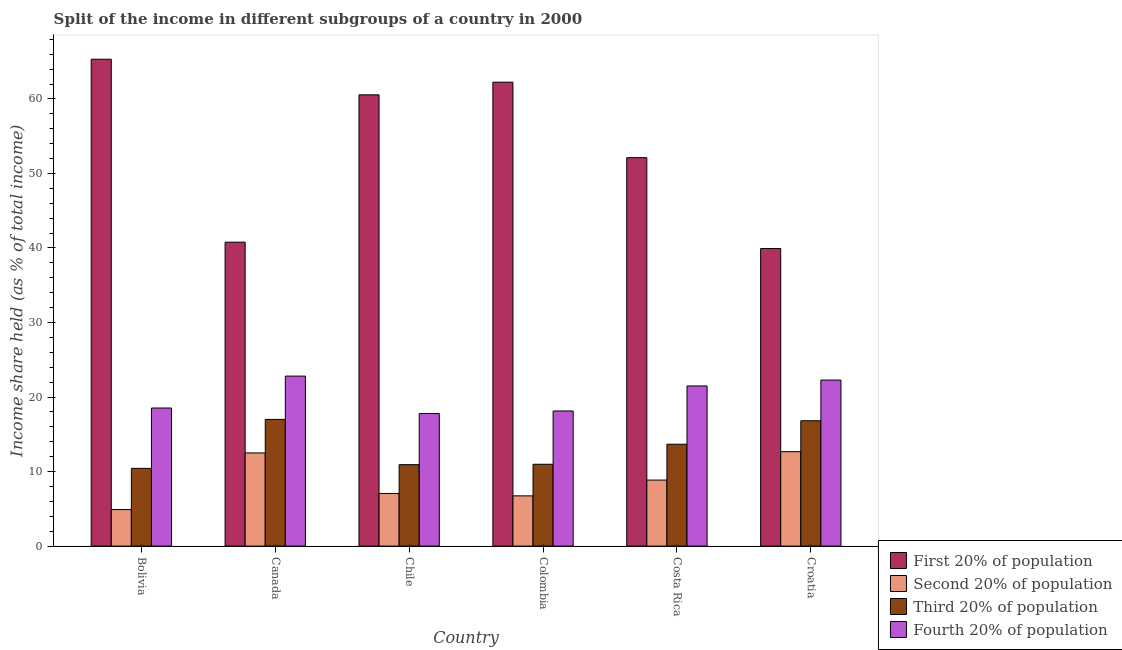How many different coloured bars are there?
Keep it short and to the point. 4. How many groups of bars are there?
Provide a succinct answer. 6. Are the number of bars per tick equal to the number of legend labels?
Give a very brief answer. Yes. Are the number of bars on each tick of the X-axis equal?
Ensure brevity in your answer.  Yes. How many bars are there on the 2nd tick from the right?
Give a very brief answer. 4. What is the label of the 4th group of bars from the left?
Offer a terse response. Colombia. What is the share of the income held by first 20% of the population in Costa Rica?
Ensure brevity in your answer.  52.12. Across all countries, what is the maximum share of the income held by first 20% of the population?
Offer a terse response. 65.33. Across all countries, what is the minimum share of the income held by first 20% of the population?
Provide a succinct answer. 39.93. What is the total share of the income held by second 20% of the population in the graph?
Provide a succinct answer. 52.73. What is the difference between the share of the income held by first 20% of the population in Chile and that in Croatia?
Provide a short and direct response. 20.62. What is the difference between the share of the income held by third 20% of the population in Chile and the share of the income held by second 20% of the population in Costa Rica?
Offer a very short reply. 2.07. What is the average share of the income held by fourth 20% of the population per country?
Offer a terse response. 20.17. What is the difference between the share of the income held by third 20% of the population and share of the income held by second 20% of the population in Costa Rica?
Provide a short and direct response. 4.81. In how many countries, is the share of the income held by third 20% of the population greater than 16 %?
Your answer should be compact. 2. What is the ratio of the share of the income held by second 20% of the population in Colombia to that in Costa Rica?
Ensure brevity in your answer.  0.76. Is the difference between the share of the income held by second 20% of the population in Bolivia and Croatia greater than the difference between the share of the income held by first 20% of the population in Bolivia and Croatia?
Provide a succinct answer. No. What is the difference between the highest and the second highest share of the income held by fourth 20% of the population?
Offer a very short reply. 0.53. What is the difference between the highest and the lowest share of the income held by second 20% of the population?
Keep it short and to the point. 7.77. In how many countries, is the share of the income held by first 20% of the population greater than the average share of the income held by first 20% of the population taken over all countries?
Ensure brevity in your answer.  3. Is the sum of the share of the income held by first 20% of the population in Chile and Costa Rica greater than the maximum share of the income held by fourth 20% of the population across all countries?
Offer a very short reply. Yes. Is it the case that in every country, the sum of the share of the income held by second 20% of the population and share of the income held by third 20% of the population is greater than the sum of share of the income held by fourth 20% of the population and share of the income held by first 20% of the population?
Keep it short and to the point. No. What does the 3rd bar from the left in Chile represents?
Offer a terse response. Third 20% of population. What does the 1st bar from the right in Bolivia represents?
Your answer should be compact. Fourth 20% of population. Is it the case that in every country, the sum of the share of the income held by first 20% of the population and share of the income held by second 20% of the population is greater than the share of the income held by third 20% of the population?
Your answer should be very brief. Yes. How many bars are there?
Provide a short and direct response. 24. Are all the bars in the graph horizontal?
Provide a short and direct response. No. Are the values on the major ticks of Y-axis written in scientific E-notation?
Give a very brief answer. No. What is the title of the graph?
Your response must be concise. Split of the income in different subgroups of a country in 2000. Does "Korea" appear as one of the legend labels in the graph?
Ensure brevity in your answer.  No. What is the label or title of the X-axis?
Provide a short and direct response. Country. What is the label or title of the Y-axis?
Ensure brevity in your answer.  Income share held (as % of total income). What is the Income share held (as % of total income) of First 20% of population in Bolivia?
Provide a succinct answer. 65.33. What is the Income share held (as % of total income) in Third 20% of population in Bolivia?
Offer a very short reply. 10.43. What is the Income share held (as % of total income) in Fourth 20% of population in Bolivia?
Your answer should be compact. 18.53. What is the Income share held (as % of total income) of First 20% of population in Canada?
Your answer should be very brief. 40.78. What is the Income share held (as % of total income) in Fourth 20% of population in Canada?
Keep it short and to the point. 22.81. What is the Income share held (as % of total income) of First 20% of population in Chile?
Your answer should be compact. 60.55. What is the Income share held (as % of total income) of Second 20% of population in Chile?
Make the answer very short. 7.06. What is the Income share held (as % of total income) in Third 20% of population in Chile?
Your answer should be very brief. 10.93. What is the Income share held (as % of total income) in Fourth 20% of population in Chile?
Offer a terse response. 17.79. What is the Income share held (as % of total income) in First 20% of population in Colombia?
Provide a succinct answer. 62.25. What is the Income share held (as % of total income) in Second 20% of population in Colombia?
Make the answer very short. 6.74. What is the Income share held (as % of total income) of Third 20% of population in Colombia?
Your answer should be compact. 10.98. What is the Income share held (as % of total income) of Fourth 20% of population in Colombia?
Your answer should be compact. 18.13. What is the Income share held (as % of total income) in First 20% of population in Costa Rica?
Provide a short and direct response. 52.12. What is the Income share held (as % of total income) of Second 20% of population in Costa Rica?
Your answer should be very brief. 8.86. What is the Income share held (as % of total income) in Third 20% of population in Costa Rica?
Give a very brief answer. 13.67. What is the Income share held (as % of total income) of Fourth 20% of population in Costa Rica?
Offer a very short reply. 21.49. What is the Income share held (as % of total income) of First 20% of population in Croatia?
Keep it short and to the point. 39.93. What is the Income share held (as % of total income) of Second 20% of population in Croatia?
Make the answer very short. 12.67. What is the Income share held (as % of total income) in Third 20% of population in Croatia?
Make the answer very short. 16.82. What is the Income share held (as % of total income) of Fourth 20% of population in Croatia?
Give a very brief answer. 22.28. Across all countries, what is the maximum Income share held (as % of total income) of First 20% of population?
Ensure brevity in your answer.  65.33. Across all countries, what is the maximum Income share held (as % of total income) in Second 20% of population?
Your response must be concise. 12.67. Across all countries, what is the maximum Income share held (as % of total income) of Third 20% of population?
Provide a short and direct response. 17. Across all countries, what is the maximum Income share held (as % of total income) of Fourth 20% of population?
Provide a succinct answer. 22.81. Across all countries, what is the minimum Income share held (as % of total income) in First 20% of population?
Provide a short and direct response. 39.93. Across all countries, what is the minimum Income share held (as % of total income) in Third 20% of population?
Offer a terse response. 10.43. Across all countries, what is the minimum Income share held (as % of total income) of Fourth 20% of population?
Provide a succinct answer. 17.79. What is the total Income share held (as % of total income) of First 20% of population in the graph?
Make the answer very short. 320.96. What is the total Income share held (as % of total income) in Second 20% of population in the graph?
Ensure brevity in your answer.  52.73. What is the total Income share held (as % of total income) of Third 20% of population in the graph?
Keep it short and to the point. 79.83. What is the total Income share held (as % of total income) in Fourth 20% of population in the graph?
Provide a succinct answer. 121.03. What is the difference between the Income share held (as % of total income) in First 20% of population in Bolivia and that in Canada?
Your answer should be very brief. 24.55. What is the difference between the Income share held (as % of total income) in Second 20% of population in Bolivia and that in Canada?
Keep it short and to the point. -7.6. What is the difference between the Income share held (as % of total income) in Third 20% of population in Bolivia and that in Canada?
Ensure brevity in your answer.  -6.57. What is the difference between the Income share held (as % of total income) of Fourth 20% of population in Bolivia and that in Canada?
Provide a succinct answer. -4.28. What is the difference between the Income share held (as % of total income) in First 20% of population in Bolivia and that in Chile?
Provide a succinct answer. 4.78. What is the difference between the Income share held (as % of total income) in Second 20% of population in Bolivia and that in Chile?
Your answer should be very brief. -2.16. What is the difference between the Income share held (as % of total income) of Third 20% of population in Bolivia and that in Chile?
Your response must be concise. -0.5. What is the difference between the Income share held (as % of total income) of Fourth 20% of population in Bolivia and that in Chile?
Your answer should be very brief. 0.74. What is the difference between the Income share held (as % of total income) in First 20% of population in Bolivia and that in Colombia?
Your response must be concise. 3.08. What is the difference between the Income share held (as % of total income) in Second 20% of population in Bolivia and that in Colombia?
Your response must be concise. -1.84. What is the difference between the Income share held (as % of total income) in Third 20% of population in Bolivia and that in Colombia?
Give a very brief answer. -0.55. What is the difference between the Income share held (as % of total income) of First 20% of population in Bolivia and that in Costa Rica?
Give a very brief answer. 13.21. What is the difference between the Income share held (as % of total income) in Second 20% of population in Bolivia and that in Costa Rica?
Provide a succinct answer. -3.96. What is the difference between the Income share held (as % of total income) in Third 20% of population in Bolivia and that in Costa Rica?
Make the answer very short. -3.24. What is the difference between the Income share held (as % of total income) of Fourth 20% of population in Bolivia and that in Costa Rica?
Your answer should be very brief. -2.96. What is the difference between the Income share held (as % of total income) of First 20% of population in Bolivia and that in Croatia?
Give a very brief answer. 25.4. What is the difference between the Income share held (as % of total income) of Second 20% of population in Bolivia and that in Croatia?
Offer a terse response. -7.77. What is the difference between the Income share held (as % of total income) in Third 20% of population in Bolivia and that in Croatia?
Offer a very short reply. -6.39. What is the difference between the Income share held (as % of total income) in Fourth 20% of population in Bolivia and that in Croatia?
Your answer should be compact. -3.75. What is the difference between the Income share held (as % of total income) of First 20% of population in Canada and that in Chile?
Ensure brevity in your answer.  -19.77. What is the difference between the Income share held (as % of total income) in Second 20% of population in Canada and that in Chile?
Keep it short and to the point. 5.44. What is the difference between the Income share held (as % of total income) in Third 20% of population in Canada and that in Chile?
Offer a terse response. 6.07. What is the difference between the Income share held (as % of total income) in Fourth 20% of population in Canada and that in Chile?
Keep it short and to the point. 5.02. What is the difference between the Income share held (as % of total income) of First 20% of population in Canada and that in Colombia?
Ensure brevity in your answer.  -21.47. What is the difference between the Income share held (as % of total income) of Second 20% of population in Canada and that in Colombia?
Provide a short and direct response. 5.76. What is the difference between the Income share held (as % of total income) in Third 20% of population in Canada and that in Colombia?
Offer a terse response. 6.02. What is the difference between the Income share held (as % of total income) in Fourth 20% of population in Canada and that in Colombia?
Ensure brevity in your answer.  4.68. What is the difference between the Income share held (as % of total income) of First 20% of population in Canada and that in Costa Rica?
Provide a succinct answer. -11.34. What is the difference between the Income share held (as % of total income) of Second 20% of population in Canada and that in Costa Rica?
Your answer should be compact. 3.64. What is the difference between the Income share held (as % of total income) in Third 20% of population in Canada and that in Costa Rica?
Your answer should be very brief. 3.33. What is the difference between the Income share held (as % of total income) of Fourth 20% of population in Canada and that in Costa Rica?
Provide a succinct answer. 1.32. What is the difference between the Income share held (as % of total income) of First 20% of population in Canada and that in Croatia?
Ensure brevity in your answer.  0.85. What is the difference between the Income share held (as % of total income) in Second 20% of population in Canada and that in Croatia?
Ensure brevity in your answer.  -0.17. What is the difference between the Income share held (as % of total income) of Third 20% of population in Canada and that in Croatia?
Keep it short and to the point. 0.18. What is the difference between the Income share held (as % of total income) of Fourth 20% of population in Canada and that in Croatia?
Make the answer very short. 0.53. What is the difference between the Income share held (as % of total income) in Second 20% of population in Chile and that in Colombia?
Your answer should be very brief. 0.32. What is the difference between the Income share held (as % of total income) in Third 20% of population in Chile and that in Colombia?
Offer a terse response. -0.05. What is the difference between the Income share held (as % of total income) in Fourth 20% of population in Chile and that in Colombia?
Offer a terse response. -0.34. What is the difference between the Income share held (as % of total income) of First 20% of population in Chile and that in Costa Rica?
Make the answer very short. 8.43. What is the difference between the Income share held (as % of total income) in Third 20% of population in Chile and that in Costa Rica?
Ensure brevity in your answer.  -2.74. What is the difference between the Income share held (as % of total income) in First 20% of population in Chile and that in Croatia?
Offer a terse response. 20.62. What is the difference between the Income share held (as % of total income) of Second 20% of population in Chile and that in Croatia?
Your answer should be compact. -5.61. What is the difference between the Income share held (as % of total income) of Third 20% of population in Chile and that in Croatia?
Make the answer very short. -5.89. What is the difference between the Income share held (as % of total income) in Fourth 20% of population in Chile and that in Croatia?
Provide a succinct answer. -4.49. What is the difference between the Income share held (as % of total income) of First 20% of population in Colombia and that in Costa Rica?
Give a very brief answer. 10.13. What is the difference between the Income share held (as % of total income) in Second 20% of population in Colombia and that in Costa Rica?
Offer a terse response. -2.12. What is the difference between the Income share held (as % of total income) in Third 20% of population in Colombia and that in Costa Rica?
Your response must be concise. -2.69. What is the difference between the Income share held (as % of total income) in Fourth 20% of population in Colombia and that in Costa Rica?
Ensure brevity in your answer.  -3.36. What is the difference between the Income share held (as % of total income) of First 20% of population in Colombia and that in Croatia?
Ensure brevity in your answer.  22.32. What is the difference between the Income share held (as % of total income) in Second 20% of population in Colombia and that in Croatia?
Your answer should be very brief. -5.93. What is the difference between the Income share held (as % of total income) of Third 20% of population in Colombia and that in Croatia?
Keep it short and to the point. -5.84. What is the difference between the Income share held (as % of total income) of Fourth 20% of population in Colombia and that in Croatia?
Provide a short and direct response. -4.15. What is the difference between the Income share held (as % of total income) in First 20% of population in Costa Rica and that in Croatia?
Give a very brief answer. 12.19. What is the difference between the Income share held (as % of total income) in Second 20% of population in Costa Rica and that in Croatia?
Your response must be concise. -3.81. What is the difference between the Income share held (as % of total income) in Third 20% of population in Costa Rica and that in Croatia?
Ensure brevity in your answer.  -3.15. What is the difference between the Income share held (as % of total income) in Fourth 20% of population in Costa Rica and that in Croatia?
Ensure brevity in your answer.  -0.79. What is the difference between the Income share held (as % of total income) in First 20% of population in Bolivia and the Income share held (as % of total income) in Second 20% of population in Canada?
Your response must be concise. 52.83. What is the difference between the Income share held (as % of total income) of First 20% of population in Bolivia and the Income share held (as % of total income) of Third 20% of population in Canada?
Make the answer very short. 48.33. What is the difference between the Income share held (as % of total income) of First 20% of population in Bolivia and the Income share held (as % of total income) of Fourth 20% of population in Canada?
Ensure brevity in your answer.  42.52. What is the difference between the Income share held (as % of total income) in Second 20% of population in Bolivia and the Income share held (as % of total income) in Fourth 20% of population in Canada?
Your response must be concise. -17.91. What is the difference between the Income share held (as % of total income) of Third 20% of population in Bolivia and the Income share held (as % of total income) of Fourth 20% of population in Canada?
Offer a terse response. -12.38. What is the difference between the Income share held (as % of total income) of First 20% of population in Bolivia and the Income share held (as % of total income) of Second 20% of population in Chile?
Provide a short and direct response. 58.27. What is the difference between the Income share held (as % of total income) in First 20% of population in Bolivia and the Income share held (as % of total income) in Third 20% of population in Chile?
Provide a short and direct response. 54.4. What is the difference between the Income share held (as % of total income) of First 20% of population in Bolivia and the Income share held (as % of total income) of Fourth 20% of population in Chile?
Ensure brevity in your answer.  47.54. What is the difference between the Income share held (as % of total income) of Second 20% of population in Bolivia and the Income share held (as % of total income) of Third 20% of population in Chile?
Provide a short and direct response. -6.03. What is the difference between the Income share held (as % of total income) in Second 20% of population in Bolivia and the Income share held (as % of total income) in Fourth 20% of population in Chile?
Provide a short and direct response. -12.89. What is the difference between the Income share held (as % of total income) in Third 20% of population in Bolivia and the Income share held (as % of total income) in Fourth 20% of population in Chile?
Offer a terse response. -7.36. What is the difference between the Income share held (as % of total income) in First 20% of population in Bolivia and the Income share held (as % of total income) in Second 20% of population in Colombia?
Offer a very short reply. 58.59. What is the difference between the Income share held (as % of total income) in First 20% of population in Bolivia and the Income share held (as % of total income) in Third 20% of population in Colombia?
Offer a very short reply. 54.35. What is the difference between the Income share held (as % of total income) in First 20% of population in Bolivia and the Income share held (as % of total income) in Fourth 20% of population in Colombia?
Offer a terse response. 47.2. What is the difference between the Income share held (as % of total income) of Second 20% of population in Bolivia and the Income share held (as % of total income) of Third 20% of population in Colombia?
Your answer should be compact. -6.08. What is the difference between the Income share held (as % of total income) of Second 20% of population in Bolivia and the Income share held (as % of total income) of Fourth 20% of population in Colombia?
Offer a very short reply. -13.23. What is the difference between the Income share held (as % of total income) of First 20% of population in Bolivia and the Income share held (as % of total income) of Second 20% of population in Costa Rica?
Make the answer very short. 56.47. What is the difference between the Income share held (as % of total income) of First 20% of population in Bolivia and the Income share held (as % of total income) of Third 20% of population in Costa Rica?
Keep it short and to the point. 51.66. What is the difference between the Income share held (as % of total income) of First 20% of population in Bolivia and the Income share held (as % of total income) of Fourth 20% of population in Costa Rica?
Make the answer very short. 43.84. What is the difference between the Income share held (as % of total income) in Second 20% of population in Bolivia and the Income share held (as % of total income) in Third 20% of population in Costa Rica?
Give a very brief answer. -8.77. What is the difference between the Income share held (as % of total income) of Second 20% of population in Bolivia and the Income share held (as % of total income) of Fourth 20% of population in Costa Rica?
Keep it short and to the point. -16.59. What is the difference between the Income share held (as % of total income) of Third 20% of population in Bolivia and the Income share held (as % of total income) of Fourth 20% of population in Costa Rica?
Provide a short and direct response. -11.06. What is the difference between the Income share held (as % of total income) in First 20% of population in Bolivia and the Income share held (as % of total income) in Second 20% of population in Croatia?
Provide a succinct answer. 52.66. What is the difference between the Income share held (as % of total income) in First 20% of population in Bolivia and the Income share held (as % of total income) in Third 20% of population in Croatia?
Give a very brief answer. 48.51. What is the difference between the Income share held (as % of total income) in First 20% of population in Bolivia and the Income share held (as % of total income) in Fourth 20% of population in Croatia?
Give a very brief answer. 43.05. What is the difference between the Income share held (as % of total income) of Second 20% of population in Bolivia and the Income share held (as % of total income) of Third 20% of population in Croatia?
Offer a very short reply. -11.92. What is the difference between the Income share held (as % of total income) in Second 20% of population in Bolivia and the Income share held (as % of total income) in Fourth 20% of population in Croatia?
Your response must be concise. -17.38. What is the difference between the Income share held (as % of total income) of Third 20% of population in Bolivia and the Income share held (as % of total income) of Fourth 20% of population in Croatia?
Your answer should be very brief. -11.85. What is the difference between the Income share held (as % of total income) of First 20% of population in Canada and the Income share held (as % of total income) of Second 20% of population in Chile?
Offer a very short reply. 33.72. What is the difference between the Income share held (as % of total income) of First 20% of population in Canada and the Income share held (as % of total income) of Third 20% of population in Chile?
Provide a short and direct response. 29.85. What is the difference between the Income share held (as % of total income) of First 20% of population in Canada and the Income share held (as % of total income) of Fourth 20% of population in Chile?
Your answer should be compact. 22.99. What is the difference between the Income share held (as % of total income) in Second 20% of population in Canada and the Income share held (as % of total income) in Third 20% of population in Chile?
Provide a succinct answer. 1.57. What is the difference between the Income share held (as % of total income) in Second 20% of population in Canada and the Income share held (as % of total income) in Fourth 20% of population in Chile?
Offer a terse response. -5.29. What is the difference between the Income share held (as % of total income) of Third 20% of population in Canada and the Income share held (as % of total income) of Fourth 20% of population in Chile?
Ensure brevity in your answer.  -0.79. What is the difference between the Income share held (as % of total income) of First 20% of population in Canada and the Income share held (as % of total income) of Second 20% of population in Colombia?
Provide a short and direct response. 34.04. What is the difference between the Income share held (as % of total income) of First 20% of population in Canada and the Income share held (as % of total income) of Third 20% of population in Colombia?
Keep it short and to the point. 29.8. What is the difference between the Income share held (as % of total income) in First 20% of population in Canada and the Income share held (as % of total income) in Fourth 20% of population in Colombia?
Keep it short and to the point. 22.65. What is the difference between the Income share held (as % of total income) of Second 20% of population in Canada and the Income share held (as % of total income) of Third 20% of population in Colombia?
Provide a succinct answer. 1.52. What is the difference between the Income share held (as % of total income) in Second 20% of population in Canada and the Income share held (as % of total income) in Fourth 20% of population in Colombia?
Offer a very short reply. -5.63. What is the difference between the Income share held (as % of total income) of Third 20% of population in Canada and the Income share held (as % of total income) of Fourth 20% of population in Colombia?
Your response must be concise. -1.13. What is the difference between the Income share held (as % of total income) of First 20% of population in Canada and the Income share held (as % of total income) of Second 20% of population in Costa Rica?
Your response must be concise. 31.92. What is the difference between the Income share held (as % of total income) of First 20% of population in Canada and the Income share held (as % of total income) of Third 20% of population in Costa Rica?
Give a very brief answer. 27.11. What is the difference between the Income share held (as % of total income) in First 20% of population in Canada and the Income share held (as % of total income) in Fourth 20% of population in Costa Rica?
Your response must be concise. 19.29. What is the difference between the Income share held (as % of total income) in Second 20% of population in Canada and the Income share held (as % of total income) in Third 20% of population in Costa Rica?
Ensure brevity in your answer.  -1.17. What is the difference between the Income share held (as % of total income) in Second 20% of population in Canada and the Income share held (as % of total income) in Fourth 20% of population in Costa Rica?
Offer a terse response. -8.99. What is the difference between the Income share held (as % of total income) in Third 20% of population in Canada and the Income share held (as % of total income) in Fourth 20% of population in Costa Rica?
Your answer should be compact. -4.49. What is the difference between the Income share held (as % of total income) of First 20% of population in Canada and the Income share held (as % of total income) of Second 20% of population in Croatia?
Offer a terse response. 28.11. What is the difference between the Income share held (as % of total income) of First 20% of population in Canada and the Income share held (as % of total income) of Third 20% of population in Croatia?
Offer a very short reply. 23.96. What is the difference between the Income share held (as % of total income) of Second 20% of population in Canada and the Income share held (as % of total income) of Third 20% of population in Croatia?
Provide a succinct answer. -4.32. What is the difference between the Income share held (as % of total income) in Second 20% of population in Canada and the Income share held (as % of total income) in Fourth 20% of population in Croatia?
Provide a short and direct response. -9.78. What is the difference between the Income share held (as % of total income) in Third 20% of population in Canada and the Income share held (as % of total income) in Fourth 20% of population in Croatia?
Offer a very short reply. -5.28. What is the difference between the Income share held (as % of total income) of First 20% of population in Chile and the Income share held (as % of total income) of Second 20% of population in Colombia?
Make the answer very short. 53.81. What is the difference between the Income share held (as % of total income) in First 20% of population in Chile and the Income share held (as % of total income) in Third 20% of population in Colombia?
Provide a succinct answer. 49.57. What is the difference between the Income share held (as % of total income) of First 20% of population in Chile and the Income share held (as % of total income) of Fourth 20% of population in Colombia?
Your response must be concise. 42.42. What is the difference between the Income share held (as % of total income) of Second 20% of population in Chile and the Income share held (as % of total income) of Third 20% of population in Colombia?
Provide a succinct answer. -3.92. What is the difference between the Income share held (as % of total income) in Second 20% of population in Chile and the Income share held (as % of total income) in Fourth 20% of population in Colombia?
Your response must be concise. -11.07. What is the difference between the Income share held (as % of total income) in First 20% of population in Chile and the Income share held (as % of total income) in Second 20% of population in Costa Rica?
Keep it short and to the point. 51.69. What is the difference between the Income share held (as % of total income) in First 20% of population in Chile and the Income share held (as % of total income) in Third 20% of population in Costa Rica?
Make the answer very short. 46.88. What is the difference between the Income share held (as % of total income) in First 20% of population in Chile and the Income share held (as % of total income) in Fourth 20% of population in Costa Rica?
Keep it short and to the point. 39.06. What is the difference between the Income share held (as % of total income) in Second 20% of population in Chile and the Income share held (as % of total income) in Third 20% of population in Costa Rica?
Your answer should be very brief. -6.61. What is the difference between the Income share held (as % of total income) in Second 20% of population in Chile and the Income share held (as % of total income) in Fourth 20% of population in Costa Rica?
Ensure brevity in your answer.  -14.43. What is the difference between the Income share held (as % of total income) of Third 20% of population in Chile and the Income share held (as % of total income) of Fourth 20% of population in Costa Rica?
Provide a short and direct response. -10.56. What is the difference between the Income share held (as % of total income) in First 20% of population in Chile and the Income share held (as % of total income) in Second 20% of population in Croatia?
Provide a short and direct response. 47.88. What is the difference between the Income share held (as % of total income) of First 20% of population in Chile and the Income share held (as % of total income) of Third 20% of population in Croatia?
Offer a terse response. 43.73. What is the difference between the Income share held (as % of total income) in First 20% of population in Chile and the Income share held (as % of total income) in Fourth 20% of population in Croatia?
Make the answer very short. 38.27. What is the difference between the Income share held (as % of total income) of Second 20% of population in Chile and the Income share held (as % of total income) of Third 20% of population in Croatia?
Your answer should be compact. -9.76. What is the difference between the Income share held (as % of total income) in Second 20% of population in Chile and the Income share held (as % of total income) in Fourth 20% of population in Croatia?
Ensure brevity in your answer.  -15.22. What is the difference between the Income share held (as % of total income) in Third 20% of population in Chile and the Income share held (as % of total income) in Fourth 20% of population in Croatia?
Make the answer very short. -11.35. What is the difference between the Income share held (as % of total income) of First 20% of population in Colombia and the Income share held (as % of total income) of Second 20% of population in Costa Rica?
Your answer should be very brief. 53.39. What is the difference between the Income share held (as % of total income) of First 20% of population in Colombia and the Income share held (as % of total income) of Third 20% of population in Costa Rica?
Your answer should be very brief. 48.58. What is the difference between the Income share held (as % of total income) in First 20% of population in Colombia and the Income share held (as % of total income) in Fourth 20% of population in Costa Rica?
Give a very brief answer. 40.76. What is the difference between the Income share held (as % of total income) in Second 20% of population in Colombia and the Income share held (as % of total income) in Third 20% of population in Costa Rica?
Provide a short and direct response. -6.93. What is the difference between the Income share held (as % of total income) of Second 20% of population in Colombia and the Income share held (as % of total income) of Fourth 20% of population in Costa Rica?
Ensure brevity in your answer.  -14.75. What is the difference between the Income share held (as % of total income) in Third 20% of population in Colombia and the Income share held (as % of total income) in Fourth 20% of population in Costa Rica?
Keep it short and to the point. -10.51. What is the difference between the Income share held (as % of total income) in First 20% of population in Colombia and the Income share held (as % of total income) in Second 20% of population in Croatia?
Your response must be concise. 49.58. What is the difference between the Income share held (as % of total income) in First 20% of population in Colombia and the Income share held (as % of total income) in Third 20% of population in Croatia?
Your answer should be very brief. 45.43. What is the difference between the Income share held (as % of total income) in First 20% of population in Colombia and the Income share held (as % of total income) in Fourth 20% of population in Croatia?
Ensure brevity in your answer.  39.97. What is the difference between the Income share held (as % of total income) in Second 20% of population in Colombia and the Income share held (as % of total income) in Third 20% of population in Croatia?
Provide a succinct answer. -10.08. What is the difference between the Income share held (as % of total income) in Second 20% of population in Colombia and the Income share held (as % of total income) in Fourth 20% of population in Croatia?
Your answer should be compact. -15.54. What is the difference between the Income share held (as % of total income) of Third 20% of population in Colombia and the Income share held (as % of total income) of Fourth 20% of population in Croatia?
Offer a terse response. -11.3. What is the difference between the Income share held (as % of total income) in First 20% of population in Costa Rica and the Income share held (as % of total income) in Second 20% of population in Croatia?
Offer a very short reply. 39.45. What is the difference between the Income share held (as % of total income) in First 20% of population in Costa Rica and the Income share held (as % of total income) in Third 20% of population in Croatia?
Offer a very short reply. 35.3. What is the difference between the Income share held (as % of total income) of First 20% of population in Costa Rica and the Income share held (as % of total income) of Fourth 20% of population in Croatia?
Give a very brief answer. 29.84. What is the difference between the Income share held (as % of total income) of Second 20% of population in Costa Rica and the Income share held (as % of total income) of Third 20% of population in Croatia?
Keep it short and to the point. -7.96. What is the difference between the Income share held (as % of total income) of Second 20% of population in Costa Rica and the Income share held (as % of total income) of Fourth 20% of population in Croatia?
Offer a terse response. -13.42. What is the difference between the Income share held (as % of total income) of Third 20% of population in Costa Rica and the Income share held (as % of total income) of Fourth 20% of population in Croatia?
Your answer should be very brief. -8.61. What is the average Income share held (as % of total income) in First 20% of population per country?
Keep it short and to the point. 53.49. What is the average Income share held (as % of total income) in Second 20% of population per country?
Your answer should be very brief. 8.79. What is the average Income share held (as % of total income) of Third 20% of population per country?
Your response must be concise. 13.3. What is the average Income share held (as % of total income) of Fourth 20% of population per country?
Offer a terse response. 20.17. What is the difference between the Income share held (as % of total income) in First 20% of population and Income share held (as % of total income) in Second 20% of population in Bolivia?
Ensure brevity in your answer.  60.43. What is the difference between the Income share held (as % of total income) in First 20% of population and Income share held (as % of total income) in Third 20% of population in Bolivia?
Provide a succinct answer. 54.9. What is the difference between the Income share held (as % of total income) of First 20% of population and Income share held (as % of total income) of Fourth 20% of population in Bolivia?
Provide a succinct answer. 46.8. What is the difference between the Income share held (as % of total income) in Second 20% of population and Income share held (as % of total income) in Third 20% of population in Bolivia?
Offer a terse response. -5.53. What is the difference between the Income share held (as % of total income) in Second 20% of population and Income share held (as % of total income) in Fourth 20% of population in Bolivia?
Your answer should be compact. -13.63. What is the difference between the Income share held (as % of total income) in Third 20% of population and Income share held (as % of total income) in Fourth 20% of population in Bolivia?
Keep it short and to the point. -8.1. What is the difference between the Income share held (as % of total income) in First 20% of population and Income share held (as % of total income) in Second 20% of population in Canada?
Provide a succinct answer. 28.28. What is the difference between the Income share held (as % of total income) in First 20% of population and Income share held (as % of total income) in Third 20% of population in Canada?
Your answer should be compact. 23.78. What is the difference between the Income share held (as % of total income) in First 20% of population and Income share held (as % of total income) in Fourth 20% of population in Canada?
Your response must be concise. 17.97. What is the difference between the Income share held (as % of total income) of Second 20% of population and Income share held (as % of total income) of Fourth 20% of population in Canada?
Offer a very short reply. -10.31. What is the difference between the Income share held (as % of total income) of Third 20% of population and Income share held (as % of total income) of Fourth 20% of population in Canada?
Offer a very short reply. -5.81. What is the difference between the Income share held (as % of total income) of First 20% of population and Income share held (as % of total income) of Second 20% of population in Chile?
Your response must be concise. 53.49. What is the difference between the Income share held (as % of total income) of First 20% of population and Income share held (as % of total income) of Third 20% of population in Chile?
Your response must be concise. 49.62. What is the difference between the Income share held (as % of total income) in First 20% of population and Income share held (as % of total income) in Fourth 20% of population in Chile?
Provide a succinct answer. 42.76. What is the difference between the Income share held (as % of total income) of Second 20% of population and Income share held (as % of total income) of Third 20% of population in Chile?
Ensure brevity in your answer.  -3.87. What is the difference between the Income share held (as % of total income) of Second 20% of population and Income share held (as % of total income) of Fourth 20% of population in Chile?
Your answer should be compact. -10.73. What is the difference between the Income share held (as % of total income) of Third 20% of population and Income share held (as % of total income) of Fourth 20% of population in Chile?
Keep it short and to the point. -6.86. What is the difference between the Income share held (as % of total income) of First 20% of population and Income share held (as % of total income) of Second 20% of population in Colombia?
Offer a terse response. 55.51. What is the difference between the Income share held (as % of total income) of First 20% of population and Income share held (as % of total income) of Third 20% of population in Colombia?
Provide a succinct answer. 51.27. What is the difference between the Income share held (as % of total income) in First 20% of population and Income share held (as % of total income) in Fourth 20% of population in Colombia?
Your answer should be compact. 44.12. What is the difference between the Income share held (as % of total income) in Second 20% of population and Income share held (as % of total income) in Third 20% of population in Colombia?
Offer a very short reply. -4.24. What is the difference between the Income share held (as % of total income) of Second 20% of population and Income share held (as % of total income) of Fourth 20% of population in Colombia?
Keep it short and to the point. -11.39. What is the difference between the Income share held (as % of total income) of Third 20% of population and Income share held (as % of total income) of Fourth 20% of population in Colombia?
Ensure brevity in your answer.  -7.15. What is the difference between the Income share held (as % of total income) of First 20% of population and Income share held (as % of total income) of Second 20% of population in Costa Rica?
Your response must be concise. 43.26. What is the difference between the Income share held (as % of total income) in First 20% of population and Income share held (as % of total income) in Third 20% of population in Costa Rica?
Your answer should be very brief. 38.45. What is the difference between the Income share held (as % of total income) in First 20% of population and Income share held (as % of total income) in Fourth 20% of population in Costa Rica?
Your answer should be compact. 30.63. What is the difference between the Income share held (as % of total income) in Second 20% of population and Income share held (as % of total income) in Third 20% of population in Costa Rica?
Make the answer very short. -4.81. What is the difference between the Income share held (as % of total income) of Second 20% of population and Income share held (as % of total income) of Fourth 20% of population in Costa Rica?
Your answer should be compact. -12.63. What is the difference between the Income share held (as % of total income) of Third 20% of population and Income share held (as % of total income) of Fourth 20% of population in Costa Rica?
Your answer should be compact. -7.82. What is the difference between the Income share held (as % of total income) of First 20% of population and Income share held (as % of total income) of Second 20% of population in Croatia?
Your answer should be very brief. 27.26. What is the difference between the Income share held (as % of total income) in First 20% of population and Income share held (as % of total income) in Third 20% of population in Croatia?
Ensure brevity in your answer.  23.11. What is the difference between the Income share held (as % of total income) of First 20% of population and Income share held (as % of total income) of Fourth 20% of population in Croatia?
Your response must be concise. 17.65. What is the difference between the Income share held (as % of total income) of Second 20% of population and Income share held (as % of total income) of Third 20% of population in Croatia?
Offer a very short reply. -4.15. What is the difference between the Income share held (as % of total income) of Second 20% of population and Income share held (as % of total income) of Fourth 20% of population in Croatia?
Offer a terse response. -9.61. What is the difference between the Income share held (as % of total income) of Third 20% of population and Income share held (as % of total income) of Fourth 20% of population in Croatia?
Offer a terse response. -5.46. What is the ratio of the Income share held (as % of total income) in First 20% of population in Bolivia to that in Canada?
Offer a very short reply. 1.6. What is the ratio of the Income share held (as % of total income) of Second 20% of population in Bolivia to that in Canada?
Offer a terse response. 0.39. What is the ratio of the Income share held (as % of total income) in Third 20% of population in Bolivia to that in Canada?
Your answer should be compact. 0.61. What is the ratio of the Income share held (as % of total income) of Fourth 20% of population in Bolivia to that in Canada?
Offer a very short reply. 0.81. What is the ratio of the Income share held (as % of total income) of First 20% of population in Bolivia to that in Chile?
Your answer should be very brief. 1.08. What is the ratio of the Income share held (as % of total income) in Second 20% of population in Bolivia to that in Chile?
Make the answer very short. 0.69. What is the ratio of the Income share held (as % of total income) of Third 20% of population in Bolivia to that in Chile?
Keep it short and to the point. 0.95. What is the ratio of the Income share held (as % of total income) in Fourth 20% of population in Bolivia to that in Chile?
Provide a short and direct response. 1.04. What is the ratio of the Income share held (as % of total income) in First 20% of population in Bolivia to that in Colombia?
Your answer should be compact. 1.05. What is the ratio of the Income share held (as % of total income) of Second 20% of population in Bolivia to that in Colombia?
Make the answer very short. 0.73. What is the ratio of the Income share held (as % of total income) in Third 20% of population in Bolivia to that in Colombia?
Keep it short and to the point. 0.95. What is the ratio of the Income share held (as % of total income) in Fourth 20% of population in Bolivia to that in Colombia?
Give a very brief answer. 1.02. What is the ratio of the Income share held (as % of total income) of First 20% of population in Bolivia to that in Costa Rica?
Give a very brief answer. 1.25. What is the ratio of the Income share held (as % of total income) of Second 20% of population in Bolivia to that in Costa Rica?
Provide a succinct answer. 0.55. What is the ratio of the Income share held (as % of total income) in Third 20% of population in Bolivia to that in Costa Rica?
Offer a terse response. 0.76. What is the ratio of the Income share held (as % of total income) of Fourth 20% of population in Bolivia to that in Costa Rica?
Ensure brevity in your answer.  0.86. What is the ratio of the Income share held (as % of total income) of First 20% of population in Bolivia to that in Croatia?
Your response must be concise. 1.64. What is the ratio of the Income share held (as % of total income) in Second 20% of population in Bolivia to that in Croatia?
Your response must be concise. 0.39. What is the ratio of the Income share held (as % of total income) of Third 20% of population in Bolivia to that in Croatia?
Your answer should be compact. 0.62. What is the ratio of the Income share held (as % of total income) in Fourth 20% of population in Bolivia to that in Croatia?
Ensure brevity in your answer.  0.83. What is the ratio of the Income share held (as % of total income) in First 20% of population in Canada to that in Chile?
Ensure brevity in your answer.  0.67. What is the ratio of the Income share held (as % of total income) of Second 20% of population in Canada to that in Chile?
Your answer should be compact. 1.77. What is the ratio of the Income share held (as % of total income) in Third 20% of population in Canada to that in Chile?
Your answer should be compact. 1.56. What is the ratio of the Income share held (as % of total income) in Fourth 20% of population in Canada to that in Chile?
Offer a terse response. 1.28. What is the ratio of the Income share held (as % of total income) of First 20% of population in Canada to that in Colombia?
Offer a very short reply. 0.66. What is the ratio of the Income share held (as % of total income) in Second 20% of population in Canada to that in Colombia?
Give a very brief answer. 1.85. What is the ratio of the Income share held (as % of total income) of Third 20% of population in Canada to that in Colombia?
Your response must be concise. 1.55. What is the ratio of the Income share held (as % of total income) in Fourth 20% of population in Canada to that in Colombia?
Provide a short and direct response. 1.26. What is the ratio of the Income share held (as % of total income) of First 20% of population in Canada to that in Costa Rica?
Your answer should be compact. 0.78. What is the ratio of the Income share held (as % of total income) of Second 20% of population in Canada to that in Costa Rica?
Make the answer very short. 1.41. What is the ratio of the Income share held (as % of total income) of Third 20% of population in Canada to that in Costa Rica?
Give a very brief answer. 1.24. What is the ratio of the Income share held (as % of total income) of Fourth 20% of population in Canada to that in Costa Rica?
Provide a short and direct response. 1.06. What is the ratio of the Income share held (as % of total income) in First 20% of population in Canada to that in Croatia?
Offer a very short reply. 1.02. What is the ratio of the Income share held (as % of total income) in Second 20% of population in Canada to that in Croatia?
Provide a short and direct response. 0.99. What is the ratio of the Income share held (as % of total income) of Third 20% of population in Canada to that in Croatia?
Ensure brevity in your answer.  1.01. What is the ratio of the Income share held (as % of total income) in Fourth 20% of population in Canada to that in Croatia?
Offer a terse response. 1.02. What is the ratio of the Income share held (as % of total income) in First 20% of population in Chile to that in Colombia?
Your answer should be compact. 0.97. What is the ratio of the Income share held (as % of total income) in Second 20% of population in Chile to that in Colombia?
Ensure brevity in your answer.  1.05. What is the ratio of the Income share held (as % of total income) in Fourth 20% of population in Chile to that in Colombia?
Offer a very short reply. 0.98. What is the ratio of the Income share held (as % of total income) in First 20% of population in Chile to that in Costa Rica?
Offer a very short reply. 1.16. What is the ratio of the Income share held (as % of total income) of Second 20% of population in Chile to that in Costa Rica?
Offer a very short reply. 0.8. What is the ratio of the Income share held (as % of total income) of Third 20% of population in Chile to that in Costa Rica?
Provide a short and direct response. 0.8. What is the ratio of the Income share held (as % of total income) in Fourth 20% of population in Chile to that in Costa Rica?
Keep it short and to the point. 0.83. What is the ratio of the Income share held (as % of total income) in First 20% of population in Chile to that in Croatia?
Your answer should be very brief. 1.52. What is the ratio of the Income share held (as % of total income) in Second 20% of population in Chile to that in Croatia?
Offer a very short reply. 0.56. What is the ratio of the Income share held (as % of total income) of Third 20% of population in Chile to that in Croatia?
Your response must be concise. 0.65. What is the ratio of the Income share held (as % of total income) in Fourth 20% of population in Chile to that in Croatia?
Your response must be concise. 0.8. What is the ratio of the Income share held (as % of total income) of First 20% of population in Colombia to that in Costa Rica?
Offer a very short reply. 1.19. What is the ratio of the Income share held (as % of total income) in Second 20% of population in Colombia to that in Costa Rica?
Keep it short and to the point. 0.76. What is the ratio of the Income share held (as % of total income) of Third 20% of population in Colombia to that in Costa Rica?
Provide a short and direct response. 0.8. What is the ratio of the Income share held (as % of total income) of Fourth 20% of population in Colombia to that in Costa Rica?
Give a very brief answer. 0.84. What is the ratio of the Income share held (as % of total income) in First 20% of population in Colombia to that in Croatia?
Provide a succinct answer. 1.56. What is the ratio of the Income share held (as % of total income) in Second 20% of population in Colombia to that in Croatia?
Provide a succinct answer. 0.53. What is the ratio of the Income share held (as % of total income) in Third 20% of population in Colombia to that in Croatia?
Make the answer very short. 0.65. What is the ratio of the Income share held (as % of total income) in Fourth 20% of population in Colombia to that in Croatia?
Make the answer very short. 0.81. What is the ratio of the Income share held (as % of total income) in First 20% of population in Costa Rica to that in Croatia?
Your answer should be very brief. 1.31. What is the ratio of the Income share held (as % of total income) of Second 20% of population in Costa Rica to that in Croatia?
Keep it short and to the point. 0.7. What is the ratio of the Income share held (as % of total income) of Third 20% of population in Costa Rica to that in Croatia?
Your response must be concise. 0.81. What is the ratio of the Income share held (as % of total income) in Fourth 20% of population in Costa Rica to that in Croatia?
Your answer should be compact. 0.96. What is the difference between the highest and the second highest Income share held (as % of total income) in First 20% of population?
Ensure brevity in your answer.  3.08. What is the difference between the highest and the second highest Income share held (as % of total income) of Second 20% of population?
Your answer should be compact. 0.17. What is the difference between the highest and the second highest Income share held (as % of total income) of Third 20% of population?
Ensure brevity in your answer.  0.18. What is the difference between the highest and the second highest Income share held (as % of total income) in Fourth 20% of population?
Ensure brevity in your answer.  0.53. What is the difference between the highest and the lowest Income share held (as % of total income) in First 20% of population?
Provide a succinct answer. 25.4. What is the difference between the highest and the lowest Income share held (as % of total income) of Second 20% of population?
Your response must be concise. 7.77. What is the difference between the highest and the lowest Income share held (as % of total income) in Third 20% of population?
Give a very brief answer. 6.57. What is the difference between the highest and the lowest Income share held (as % of total income) in Fourth 20% of population?
Your answer should be very brief. 5.02. 